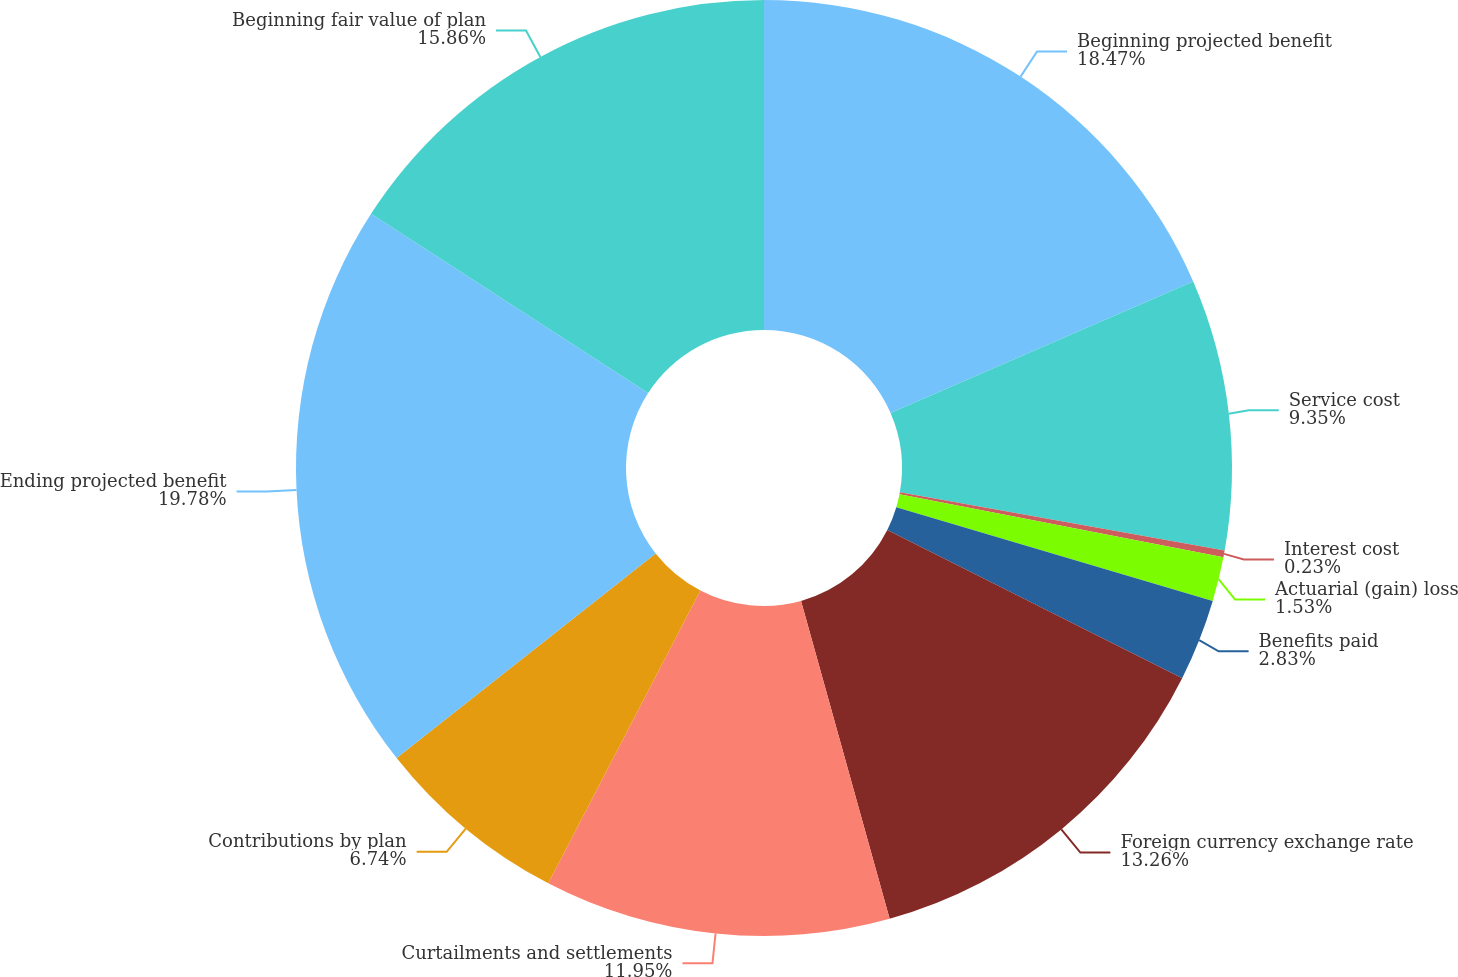Convert chart. <chart><loc_0><loc_0><loc_500><loc_500><pie_chart><fcel>Beginning projected benefit<fcel>Service cost<fcel>Interest cost<fcel>Actuarial (gain) loss<fcel>Benefits paid<fcel>Foreign currency exchange rate<fcel>Curtailments and settlements<fcel>Contributions by plan<fcel>Ending projected benefit<fcel>Beginning fair value of plan<nl><fcel>18.47%<fcel>9.35%<fcel>0.23%<fcel>1.53%<fcel>2.83%<fcel>13.26%<fcel>11.95%<fcel>6.74%<fcel>19.77%<fcel>15.86%<nl></chart> 